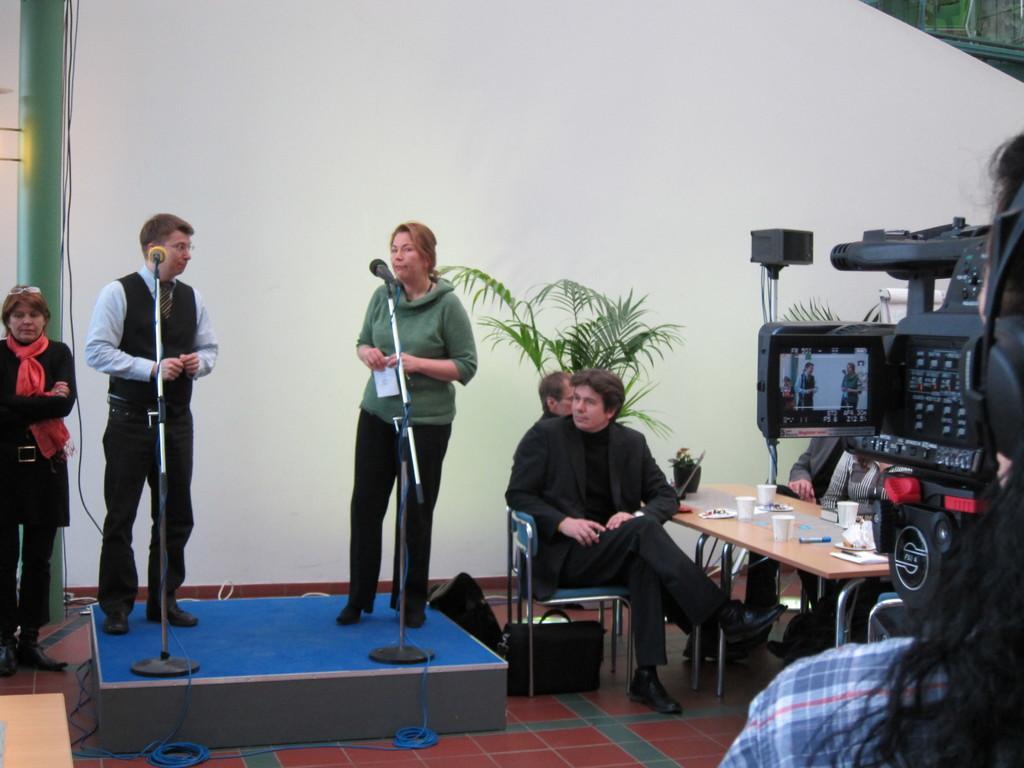Describe this image in one or two sentences. In this image a person and a woman are standing on the stage having two mike stands on it. Beside there is a person sitting on the chair. He is wearing suit. Few bags are on the floor. There is a table having few cups and a pen are on it. Behind it there are few persons sitting. Right side there is a person holding a camera. Left side there is a person standing. Person is wearing a scarf. Background there is wall. 